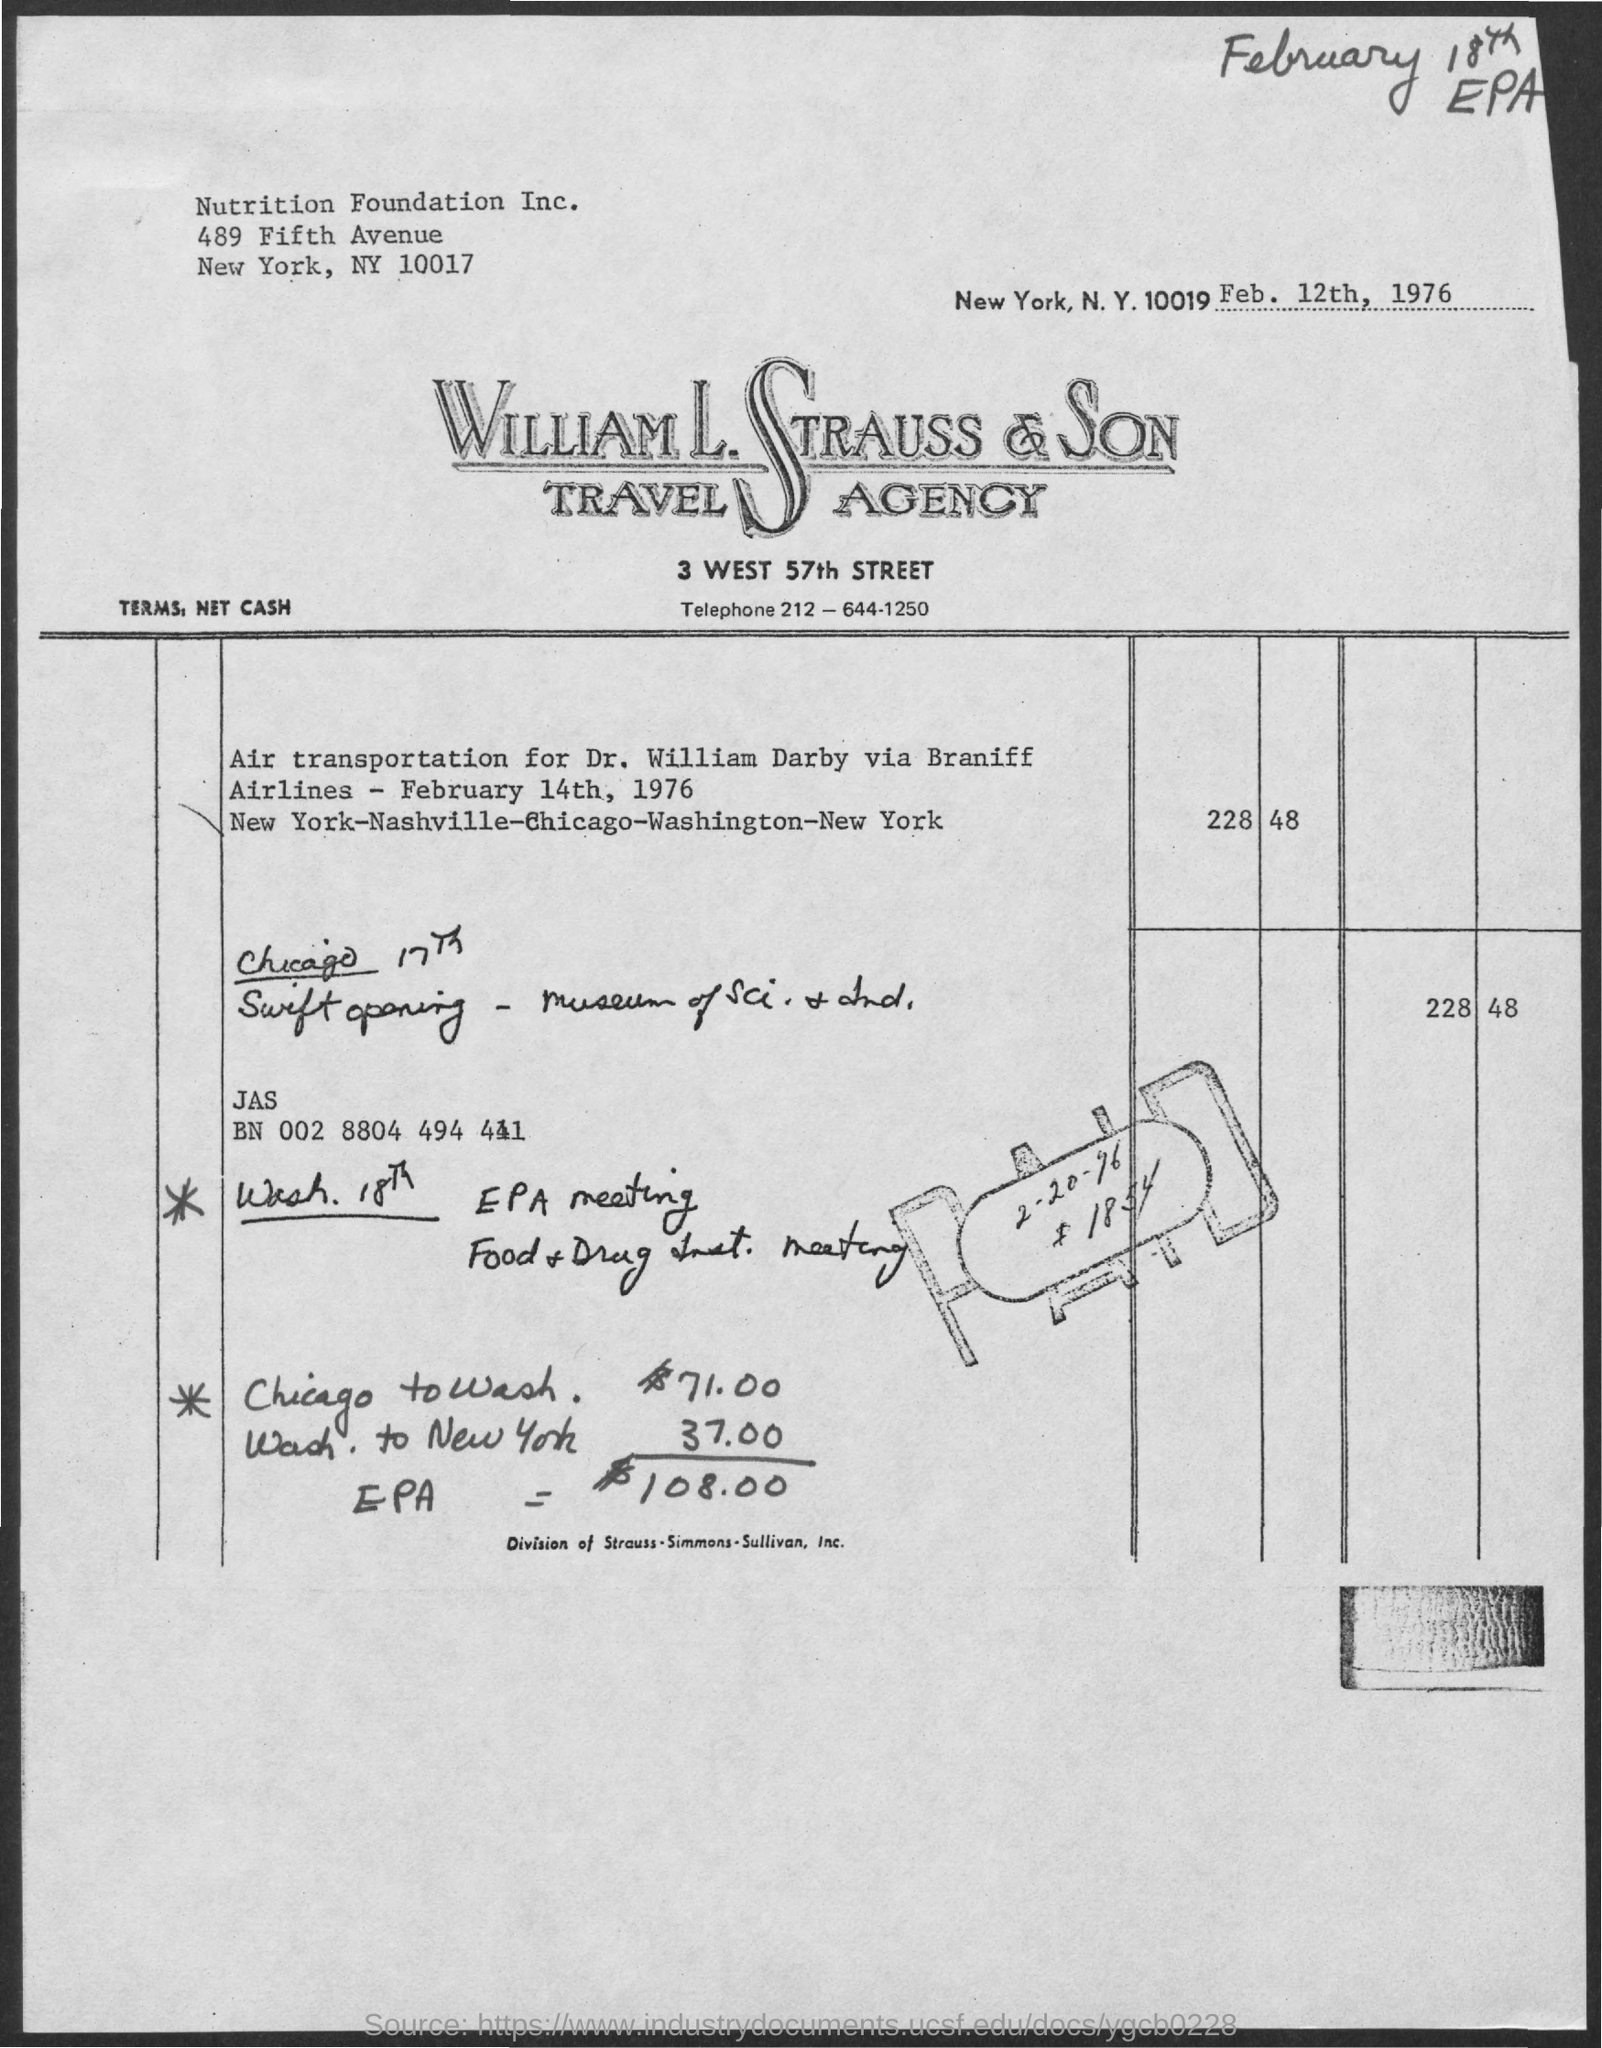Specify some key components in this picture. The date mentioned is "2/20/96. 